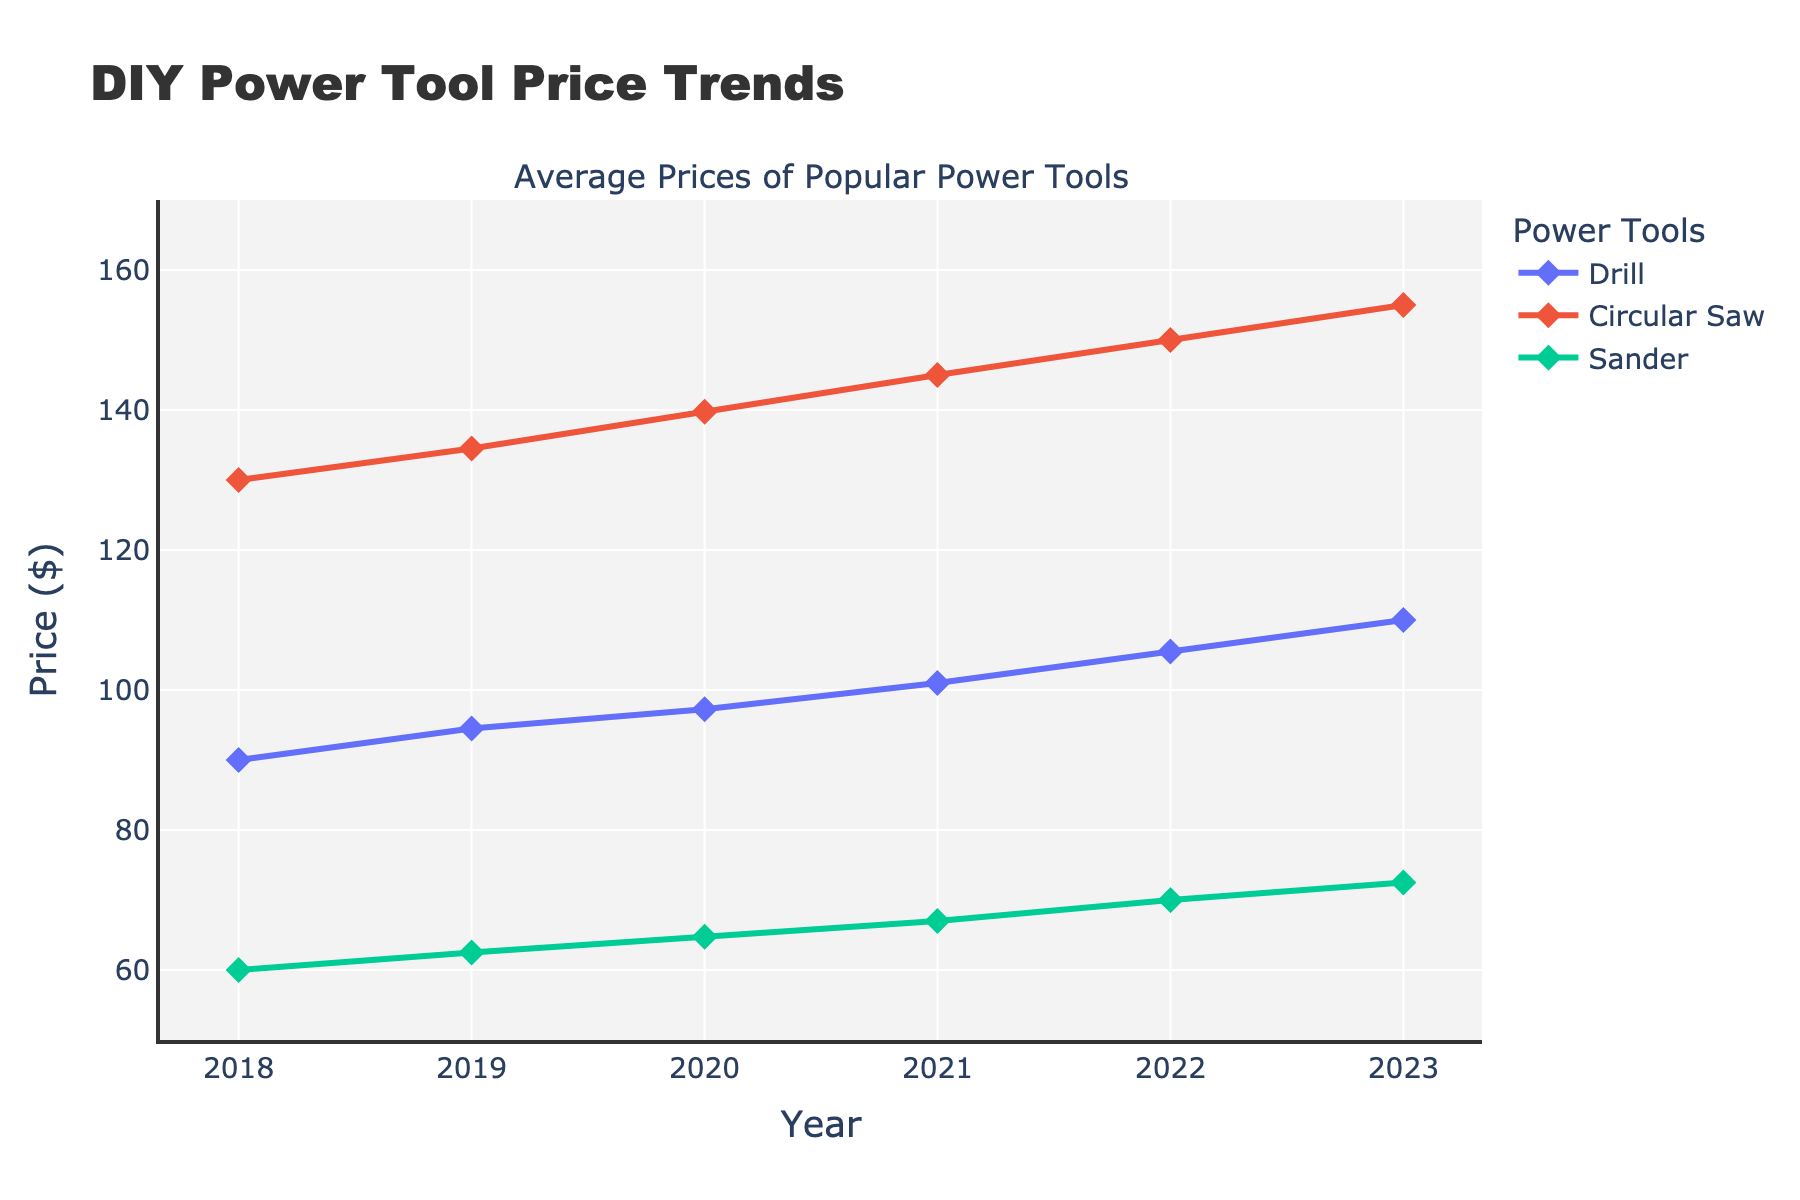What's the price increase of the Drill from 2018 to 2023? First, locate the price of the Drill in 2018, which is $89.99. Then, find the price in 2023, which is $109.99. Subtract the 2018 price from the 2023 price: $109.99 - $89.99 = $20.00.
Answer: $20.00 Which tool had the highest price increase over the 5-year period? Calculate the price increase for each tool: 
- Drill: $109.99 - $89.99 = $20.00
- Circular Saw: $154.99 - $129.99 = $25.00
- Sander: $72.50 - $59.99 = $12.51 
The Circular Saw had the highest price increase.
Answer: Circular Saw What is the average price of the Circular Saw over the 5 years? Add up the yearly prices for the Circular Saw: $129.99 + $134.50 + $139.75 + $145.00 + $149.99 + $154.99. The total is $854.22. Divide this sum by 6 years: $854.22 / 6 = $142.37.
Answer: $142.37 Does the price trend of the Sander increase more steadily compared to the Circular Saw? Check the price increments for each year for both tools: 
- Sander: 2018-2019: $2.51, 2019-2020: $2.25, 2020-2021: $2.25, 2021-2022: $2.99, 2022-2023: $2.51
- Circular Saw: 2018-2019: $4.51, 2019-2020: $5.25, 2020-2021: $5.25, 2021-2022: $4.99, 2022-2023: $5.00
The Sander shows more consistent and smaller increments compared to the Circular Saw.
Answer: Yes Which tool had the smallest price change from 2022 to 2023? Calculate the price change for each tool from 2022 to 2023: 
- Drill: $109.99 - $105.50 = $4.49
- Circular Saw: $154.99 - $149.99 = $5.00
- Sander: $72.50 - $69.99 = $2.51 
The Sander had the smallest price change.
Answer: Sander In what year did the average price of the Drill surpass $100? Check the prices of the Drill each year and find the first year above $100: 
- 2018: $89.99
- 2019: $94.50
- 2020: $97.25
- 2021: $101.00 
The Drill's average price first surpassed $100 in 2021.
Answer: 2021 